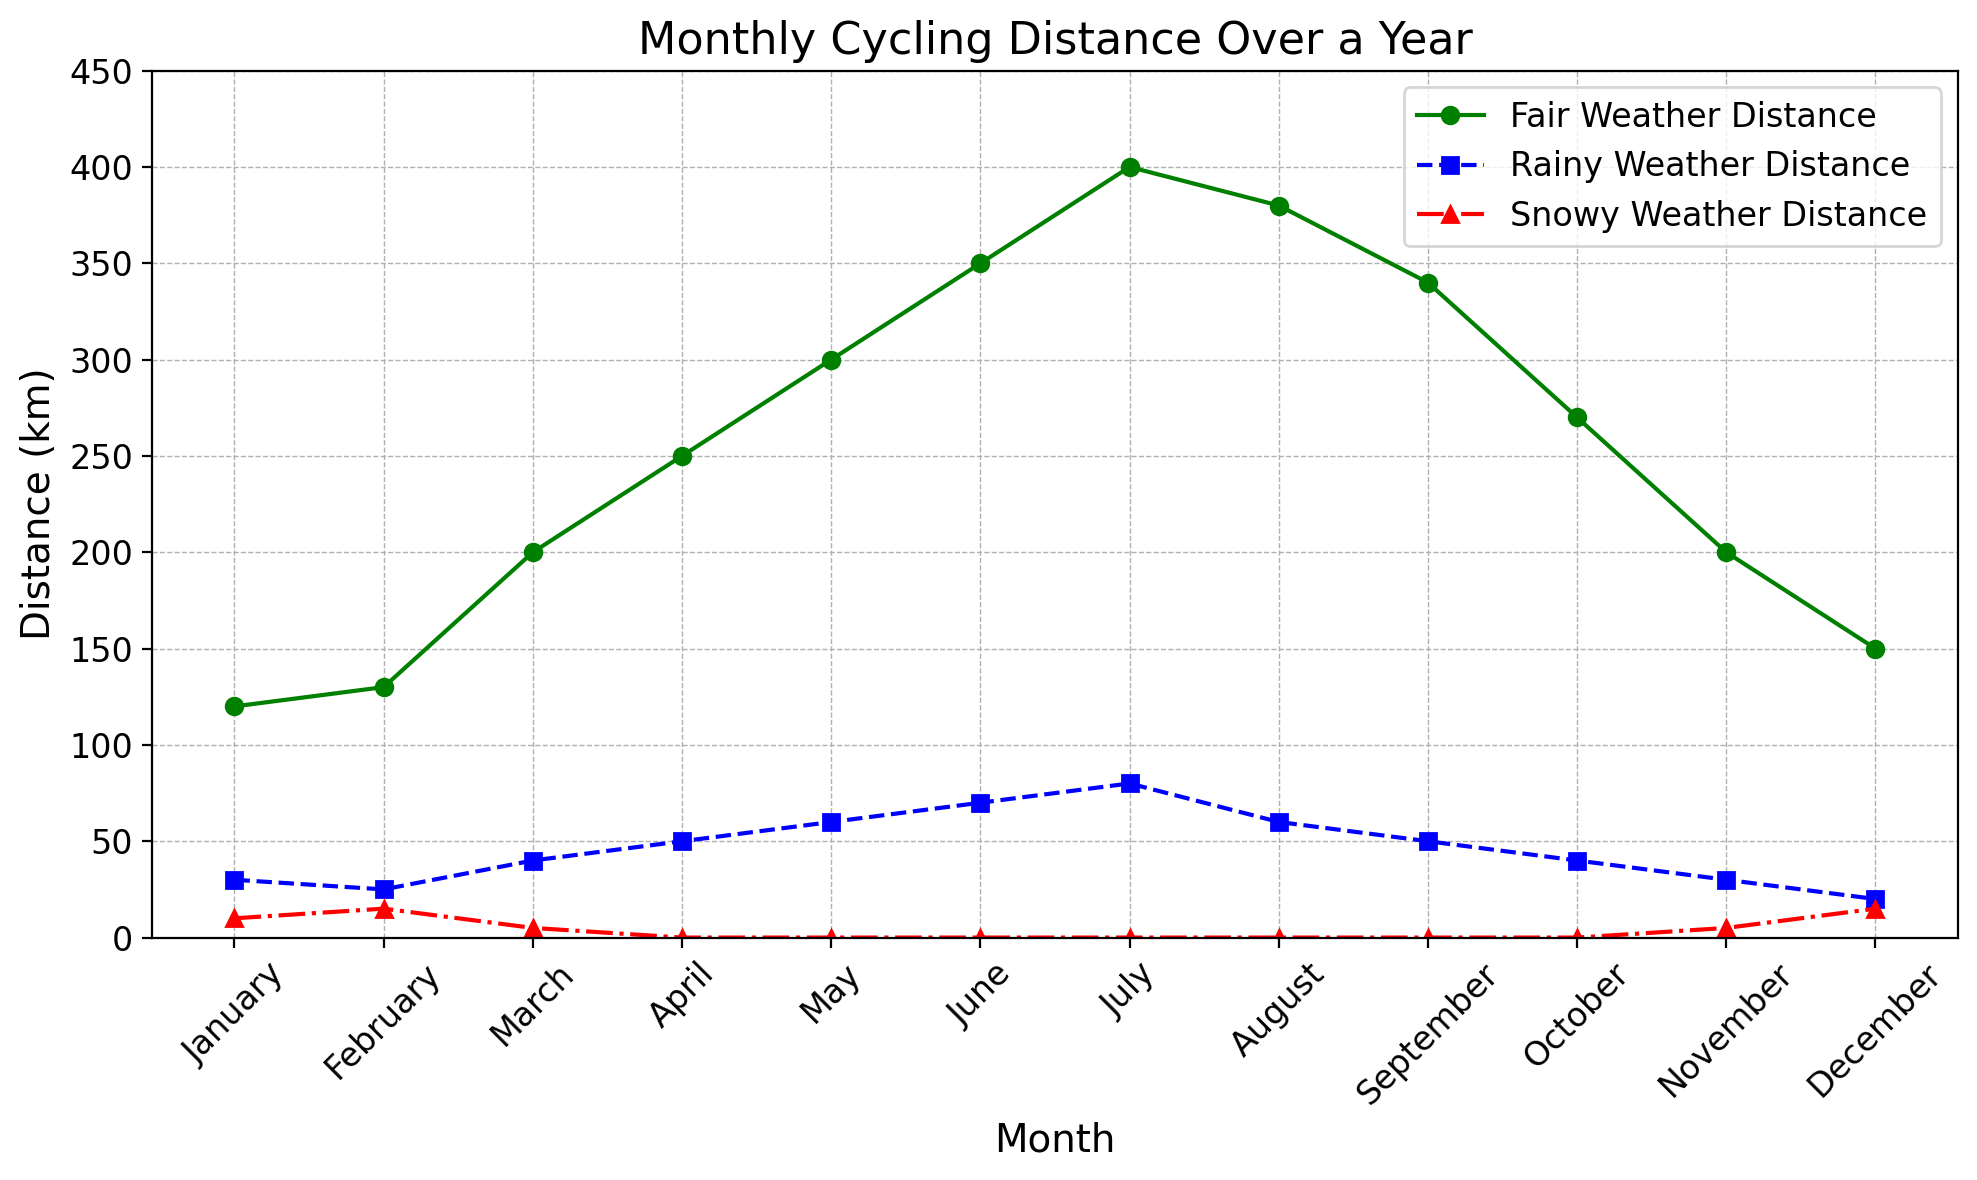Which month has the highest fair weather cycling distance? Look at the green line representing fair weather distances and identify the highest point along the y-axis on the graph. This occurs in July.
Answer: July In which month is the difference between fair weather distance and rainy weather distance the smallest? Calculate the difference between the fair weather and rainy weather distances for each month and find the month with the smallest difference. For December, the difference is smallest (150 - 20 = 130 km).
Answer: December What is the total cycling distance in January across all weather conditions? Sum up the distances for fair, rainy, and snowy weather in January. Fair weather: 120 km, Rainy weather: 30 km, Snowy weather: 10 km. 120 + 30 + 10 = 160 km.
Answer: 160 km Which month experienced the highest amount of snowy weather cycling? Identify the highest point of the red line representing snowy weather distances. This occurs in January and December, where the distance is 15 km.
Answer: January and December Compare the rainy weather distances in March and November. Which month had more rainy weather cycling? Compare the blue lines for March (40 km) and November (30 km). March had more rainy weather cycling than November.
Answer: March What is the overall trend of fair weather cycling distances over the year? Observing the green line from January to December, it starts low, increases to a peak in July, and then decreases towards December. It shows a rising trend till July and a falling trend thereafter.
Answer: Rising till July, then falling In which month(s) is there no snowy weather cycling recorded? Look at the red line; zero snowy weather distance is recorded in April until October, inclusive.
Answer: April to October How much more distance did cyclists cover in fair weather than in rainy weather in May? Subtract the rainy weather distance from the fair weather distance for May. Fair weather: 300 km, Rainy weather: 60 km. 300 - 60 = 240 km.
Answer: 240 km What color represents rainy weather cycling distances in the figure? Identifying the visual attributes in the legend, the rainy weather distances are represented by the blue line with square markers.
Answer: Blue 